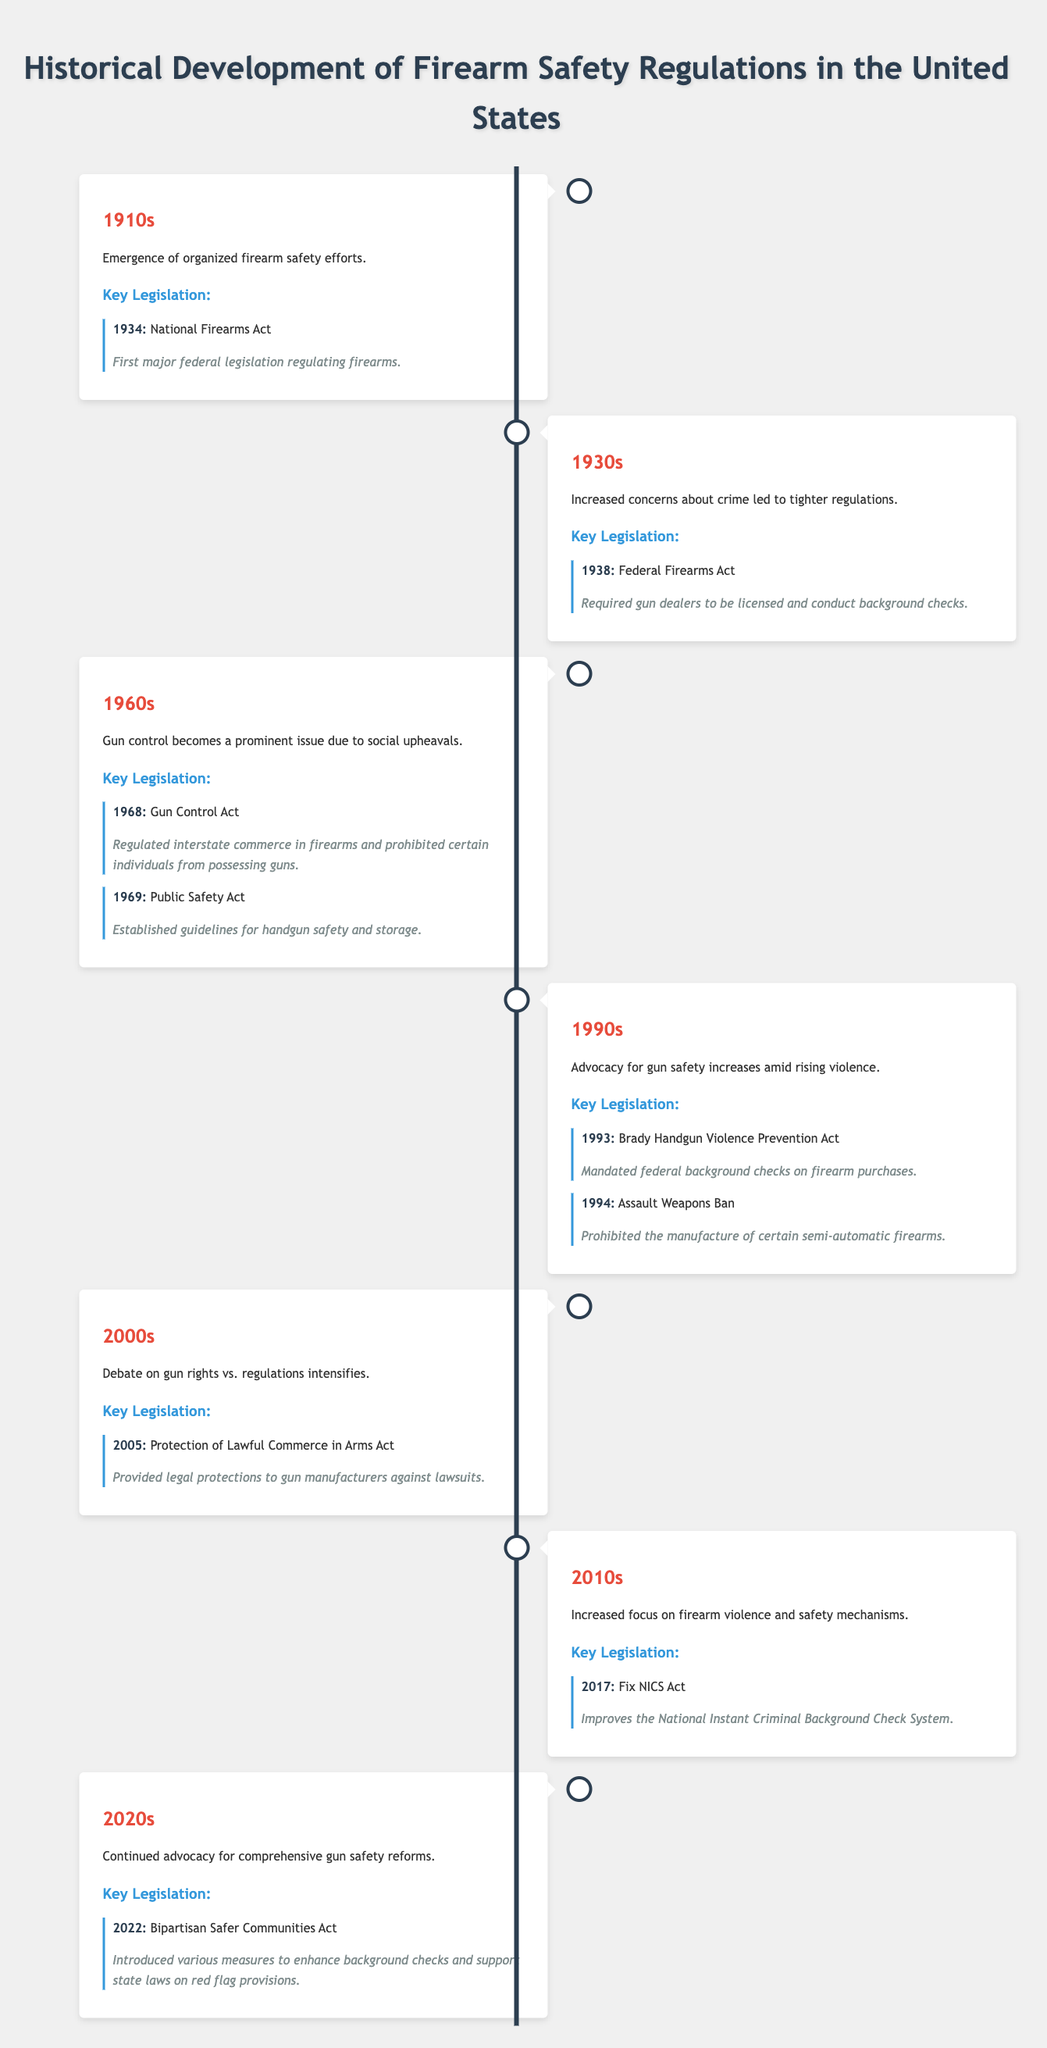What is the key legislation from the 1910s? The table lists the key legislation from the 1910s as the National Firearms Act, which was enacted in 1934.
Answer: National Firearms Act (1934) Which decade saw the introduction of the Federal Firearms Act? According to the table, the Federal Firearms Act was introduced in the 1930s, specifically in 1938.
Answer: 1930s Did the Gun Control Act of 1968 establish guidelines for handgun safety and storage? The table indicates that the Gun Control Act did not establish guidelines for handgun safety; this was instead established by the Public Safety Act in 1969.
Answer: No How many key legislations were introduced in the 1960s? The table lists two key pieces of legislation from the 1960s: the Gun Control Act (1968) and the Public Safety Act (1969). Therefore, there are two key legislations.
Answer: 2 What was the focus of firearm safety regulations in the 1990s? The overview for the 1990s states that there was an increased advocacy for gun safety amid rising violence, indicating a focus on firearm safety.
Answer: Increased advocacy for gun safety What year was the Brady Handgun Violence Prevention Act enacted? The table specifies that the Brady Handgun Violence Prevention Act was enacted in 1993.
Answer: 1993 Was the Bipartisan Safer Communities Act focused on enhancing background checks? The description of the Bipartisan Safer Communities Act states it introduced measures to enhance background checks, confirming that it was focused on this area.
Answer: Yes What can be inferred about the trend of firearm safety regulations from the 2000s to the 2020s? The table indicates a shift from legal protections for manufacturers in the 2000s to continued advocacy for comprehensive gun safety reforms in the 2020s, suggesting a growing concern for regulation over manufacturer's rights.
Answer: Increasing focus on regulation How many years passed between the introduction of the National Firearms Act and the Brady Handgun Violence Prevention Act? The National Firearms Act was introduced in 1934 and the Brady Handgun Violence Prevention Act was introduced in 1993. The difference is 1993 - 1934 = 59 years.
Answer: 59 years 